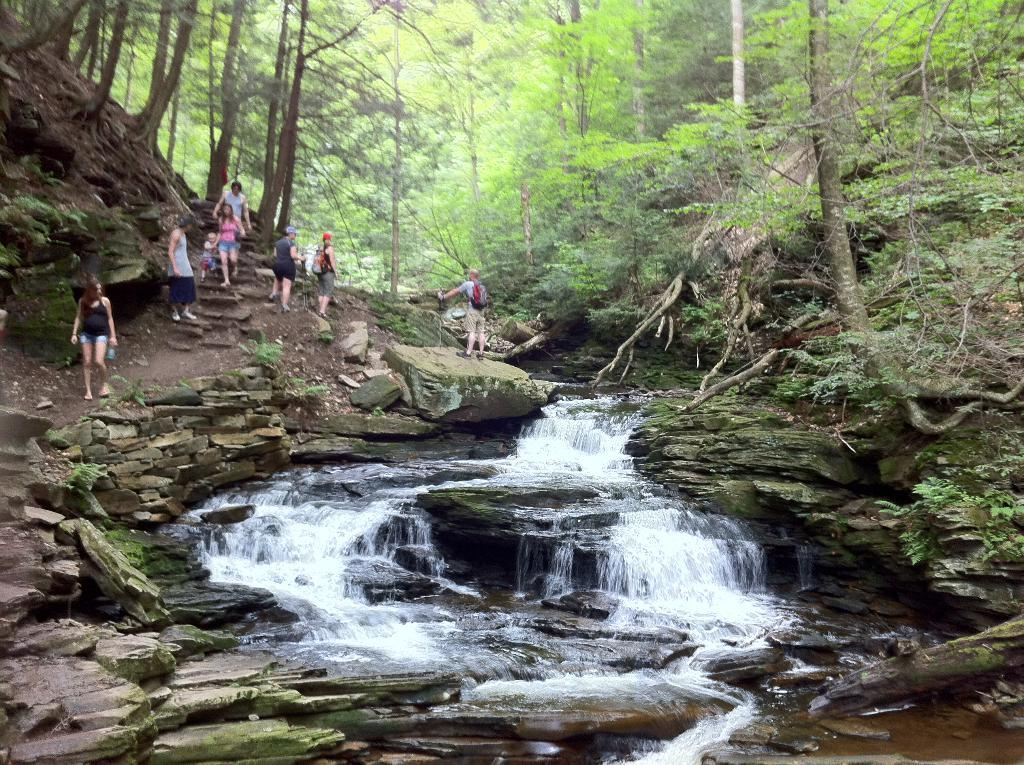What type of natural objects can be seen in the image? There are rocks, plants, trees, and a waterfall in the image. What are the people in the image doing? The people in the image are walking and holding slippers. Are there any rocks near the waterfall? Yes, there are rocks near the waterfall in the image. What type of flag can be seen near the lake in the image? There is no flag or lake present in the image. Can you describe the foot of the person walking near the waterfall? There is no specific detail about the person's foot visible in the image. 